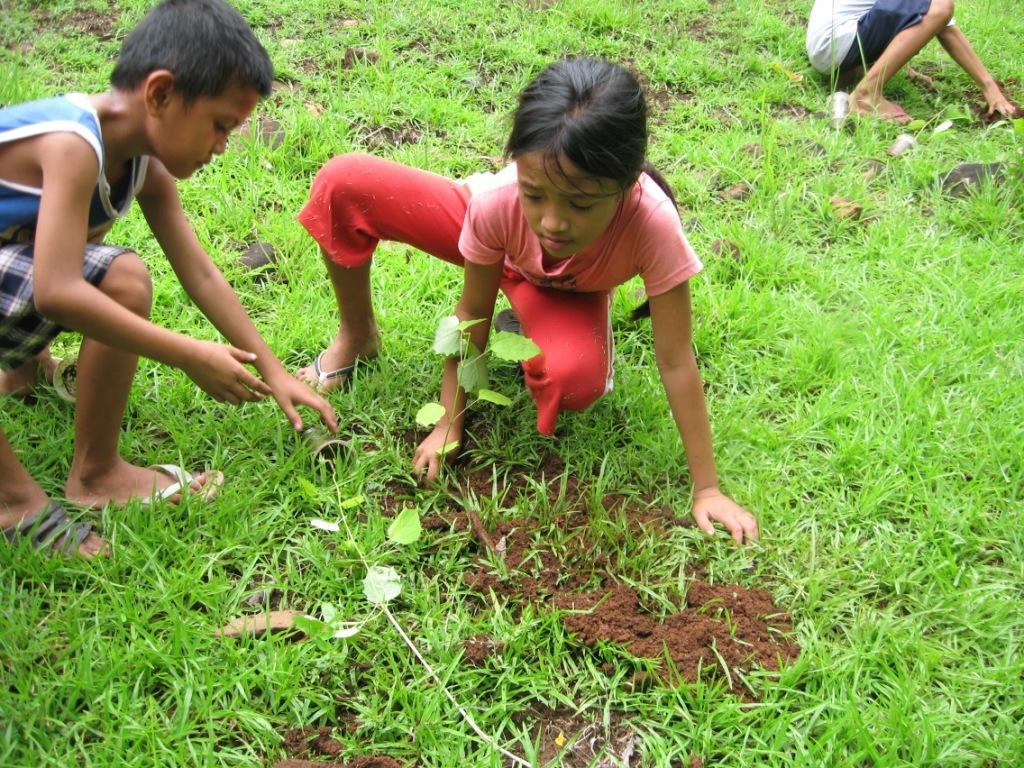What type of people can be seen in the image? There are children in the image. What type of vegetation is visible in the image? There is grass visible in the image. Can you describe the girl in the image? The girl in the image is wearing a t-shirt and pants. What type of jeans is the girl wearing in the image? The girl is not wearing jeans in the image; she is wearing pants. Is the girl wearing a crown in the image? There is no crown visible in the image. 